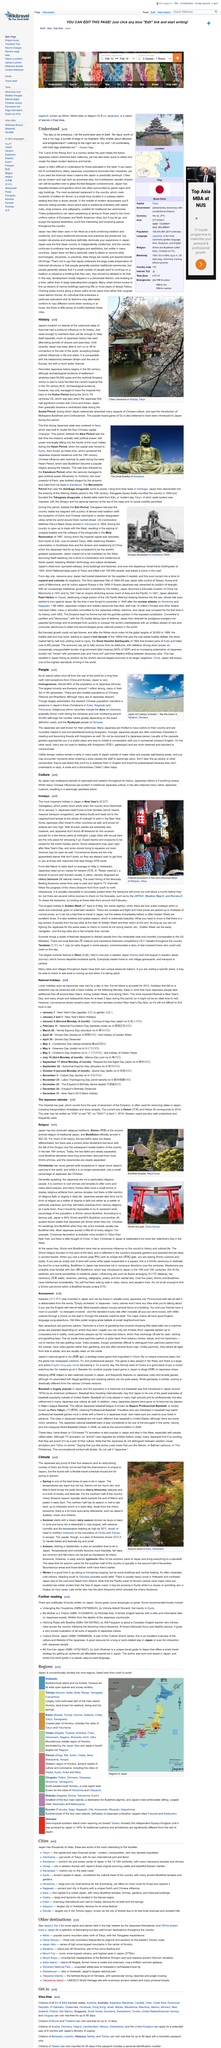Outline some significant characteristics in this image. Japan has been able to turn on and off its connection to the rest of the world in its history. Cherry blossom season typically begins towards the end of March and peaks in early April in the southern half of Japan. Japan is sometimes referred to as the 'Land of the Rising Sun,' a phrase that highlights its cultural and geographical significance. Yes, Japan has foreign cultural influences, as evidenced by the presence of Western-style buildings in its cities, the popularity of Western music and movies, and the incorporation of foreign ideas and techniques into traditional Japanese art forms such as tea ceremonies and flower arranging. Christianity has never gained widespread acceptance in Japan. 